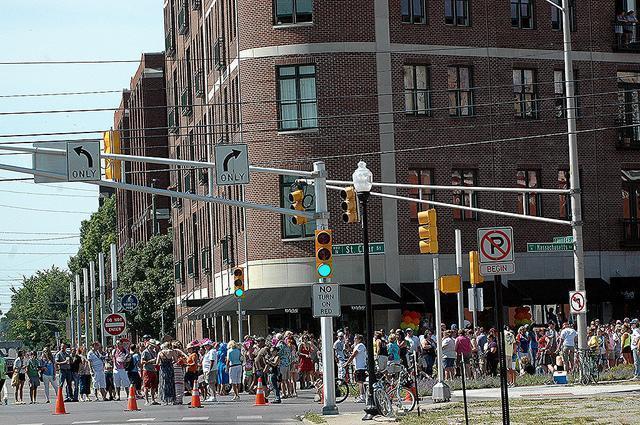Why are the traffic cones positioned in the location that they are?
Indicate the correct response by choosing from the four available options to answer the question.
Options: Directions, road closure, art, construction. Road closure. 